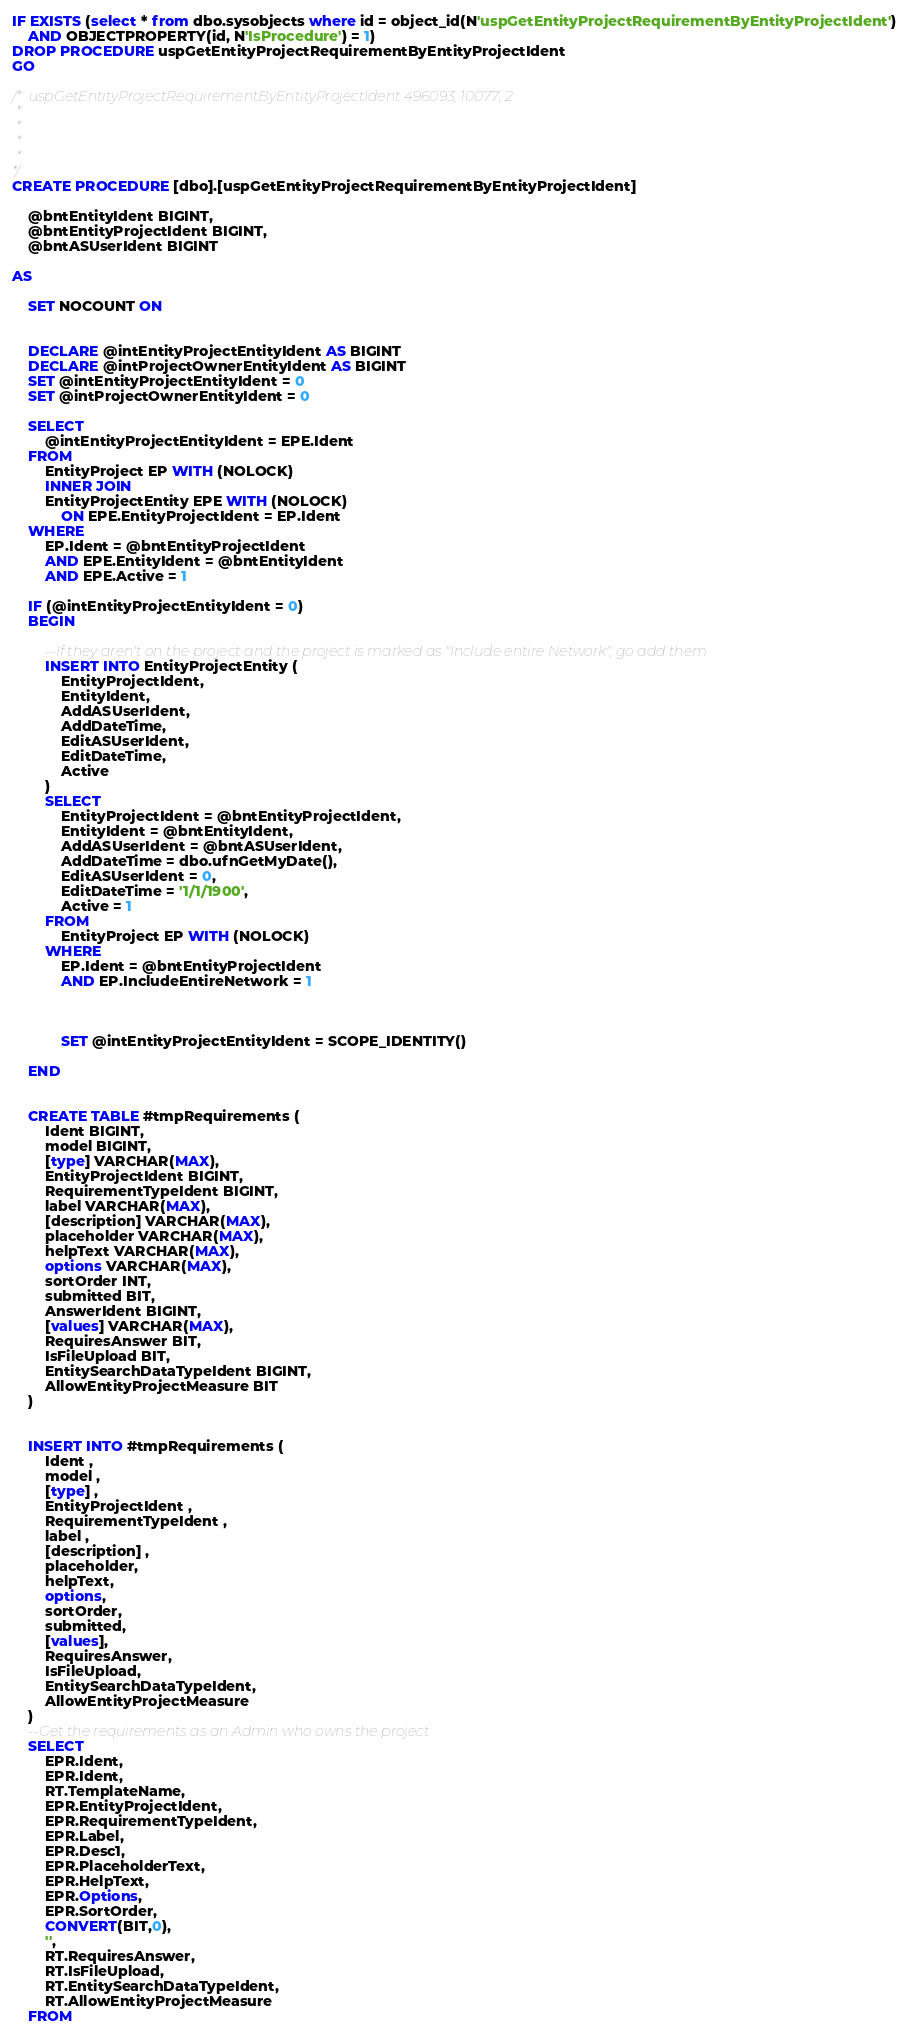<code> <loc_0><loc_0><loc_500><loc_500><_SQL_>IF EXISTS (select * from dbo.sysobjects where id = object_id(N'uspGetEntityProjectRequirementByEntityProjectIdent') 
	AND OBJECTPROPERTY(id, N'IsProcedure') = 1)
DROP PROCEDURE uspGetEntityProjectRequirementByEntityProjectIdent
GO

/* uspGetEntityProjectRequirementByEntityProjectIdent 496093, 10077, 2
 *
 *
 *
 *
*/
CREATE PROCEDURE [dbo].[uspGetEntityProjectRequirementByEntityProjectIdent]

	@bntEntityIdent BIGINT,
	@bntEntityProjectIdent BIGINT,
	@bntASUserIdent BIGINT

AS

	SET NOCOUNT ON


	DECLARE @intEntityProjectEntityIdent AS BIGINT
	DECLARE @intProjectOwnerEntityIdent AS BIGINT
	SET @intEntityProjectEntityIdent = 0
	SET @intProjectOwnerEntityIdent = 0

	SELECT 
		@intEntityProjectEntityIdent = EPE.Ident
	FROM
		EntityProject EP WITH (NOLOCK)
		INNER JOIN
		EntityProjectEntity EPE WITH (NOLOCK)
			ON EPE.EntityProjectIdent = EP.Ident
	WHERE 
		EP.Ident = @bntEntityProjectIdent
		AND EPE.EntityIdent = @bntEntityIdent
		AND EPE.Active = 1

	IF (@intEntityProjectEntityIdent = 0)
	BEGIN

		--If they aren't on the project and the project is marked as "Include entire Network", go add them
		INSERT INTO EntityProjectEntity (
			EntityProjectIdent,
			EntityIdent,
			AddASUserIdent,
			AddDateTime,
			EditASUserIdent,
			EditDateTime,
			Active
		)
		SELECT 
			EntityProjectIdent = @bntEntityProjectIdent,
			EntityIdent = @bntEntityIdent,
			AddASUserIdent = @bntASUserIdent,
			AddDateTime = dbo.ufnGetMyDate(),
			EditASUserIdent = 0,
			EditDateTime = '1/1/1900',
			Active = 1
		FROM
			EntityProject EP WITH (NOLOCK)
		WHERE 
			EP.Ident = @bntEntityProjectIdent
			AND EP.IncludeEntireNetwork = 1


				
			SET @intEntityProjectEntityIdent = SCOPE_IDENTITY()

	END


	CREATE TABLE #tmpRequirements (
		Ident BIGINT,
		model BIGINT,
		[type] VARCHAR(MAX),
		EntityProjectIdent BIGINT,
		RequirementTypeIdent BIGINT,
		label VARCHAR(MAX),
		[description] VARCHAR(MAX),
		placeholder VARCHAR(MAX),
		helpText VARCHAR(MAX),
		options VARCHAR(MAX),
		sortOrder INT,
		submitted BIT,
		AnswerIdent BIGINT,
		[values] VARCHAR(MAX),
		RequiresAnswer BIT,
		IsFileUpload BIT,
		EntitySearchDataTypeIdent BIGINT,
		AllowEntityProjectMeasure BIT
	)


	INSERT INTO #tmpRequirements (
		Ident ,
		model ,
		[type] ,
		EntityProjectIdent ,
		RequirementTypeIdent ,
		label ,
		[description] ,
		placeholder,
		helpText,
		options,
		sortOrder,
		submitted,
		[values],
		RequiresAnswer,
		IsFileUpload,
		EntitySearchDataTypeIdent,
		AllowEntityProjectMeasure
	)
	--Get the requirements as an Admin who owns the project
	SELECT 
		EPR.Ident,
		EPR.Ident,
		RT.TemplateName,
		EPR.EntityProjectIdent,
		EPR.RequirementTypeIdent,
		EPR.Label,
		EPR.Desc1,
		EPR.PlaceholderText,
		EPR.HelpText,
		EPR.Options,
		EPR.SortOrder,
		CONVERT(BIT,0),
		'',
		RT.RequiresAnswer,
		RT.IsFileUpload,
		RT.EntitySearchDataTypeIdent,
		RT.AllowEntityProjectMeasure
	FROM</code> 